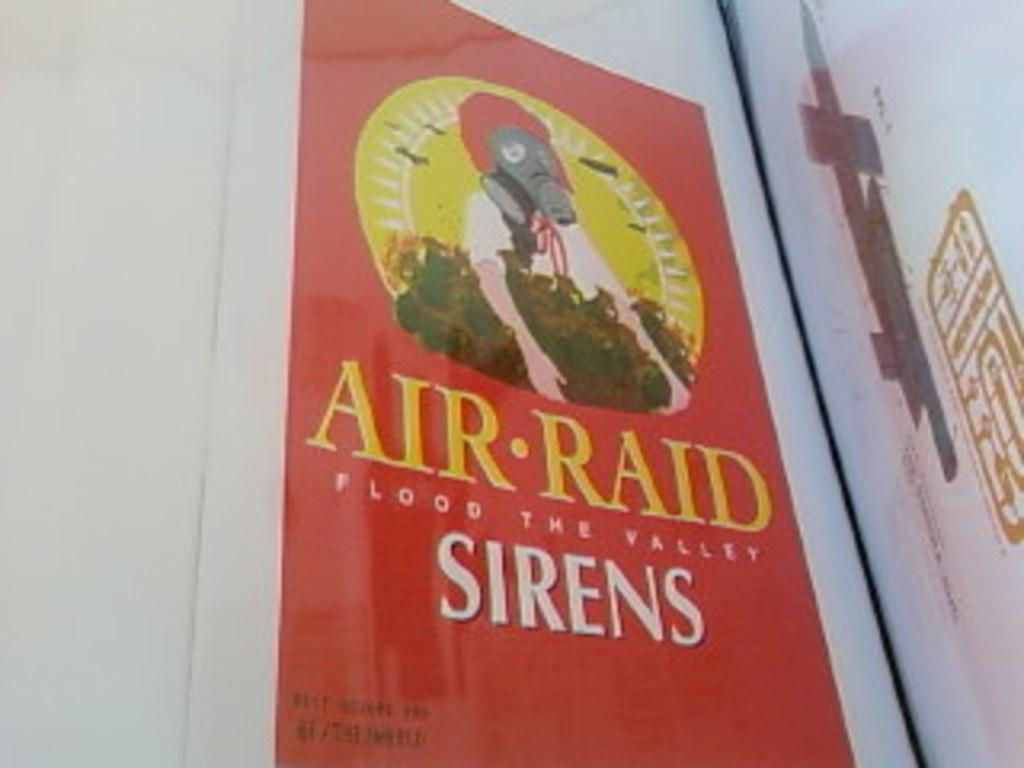<image>
Share a concise interpretation of the image provided. The Air Raid Sirens poster is a parody of the original poster. 